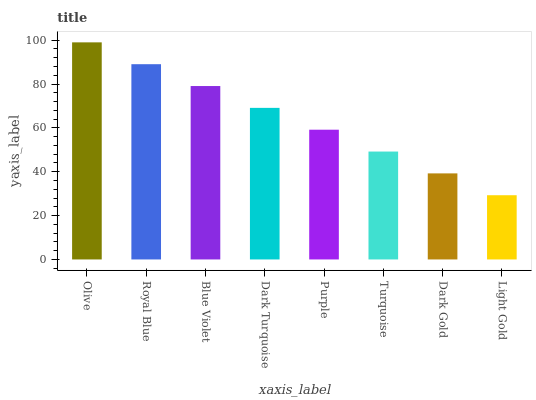Is Light Gold the minimum?
Answer yes or no. Yes. Is Olive the maximum?
Answer yes or no. Yes. Is Royal Blue the minimum?
Answer yes or no. No. Is Royal Blue the maximum?
Answer yes or no. No. Is Olive greater than Royal Blue?
Answer yes or no. Yes. Is Royal Blue less than Olive?
Answer yes or no. Yes. Is Royal Blue greater than Olive?
Answer yes or no. No. Is Olive less than Royal Blue?
Answer yes or no. No. Is Dark Turquoise the high median?
Answer yes or no. Yes. Is Purple the low median?
Answer yes or no. Yes. Is Royal Blue the high median?
Answer yes or no. No. Is Dark Gold the low median?
Answer yes or no. No. 